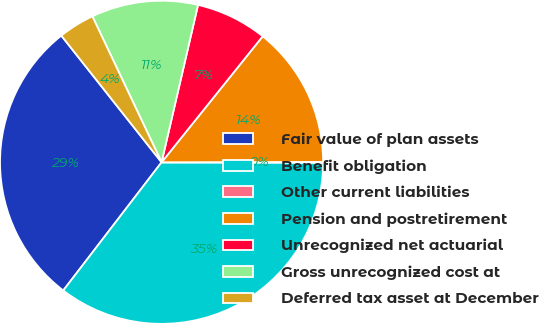<chart> <loc_0><loc_0><loc_500><loc_500><pie_chart><fcel>Fair value of plan assets<fcel>Benefit obligation<fcel>Other current liabilities<fcel>Pension and postretirement<fcel>Unrecognized net actuarial<fcel>Gross unrecognized cost at<fcel>Deferred tax asset at December<nl><fcel>28.93%<fcel>35.37%<fcel>0.08%<fcel>14.2%<fcel>7.14%<fcel>10.67%<fcel>3.61%<nl></chart> 